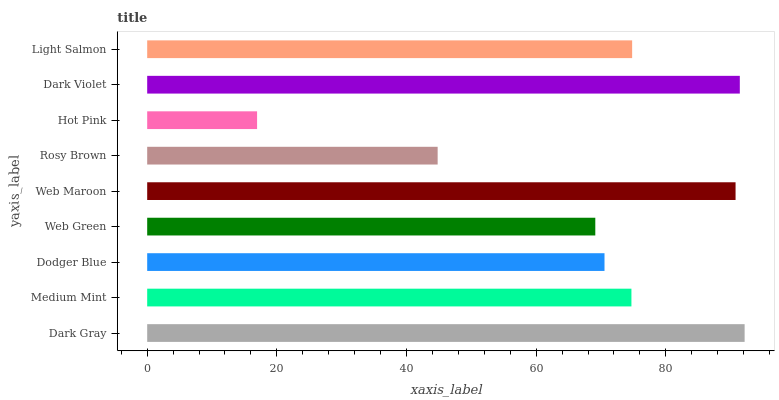Is Hot Pink the minimum?
Answer yes or no. Yes. Is Dark Gray the maximum?
Answer yes or no. Yes. Is Medium Mint the minimum?
Answer yes or no. No. Is Medium Mint the maximum?
Answer yes or no. No. Is Dark Gray greater than Medium Mint?
Answer yes or no. Yes. Is Medium Mint less than Dark Gray?
Answer yes or no. Yes. Is Medium Mint greater than Dark Gray?
Answer yes or no. No. Is Dark Gray less than Medium Mint?
Answer yes or no. No. Is Medium Mint the high median?
Answer yes or no. Yes. Is Medium Mint the low median?
Answer yes or no. Yes. Is Rosy Brown the high median?
Answer yes or no. No. Is Dodger Blue the low median?
Answer yes or no. No. 